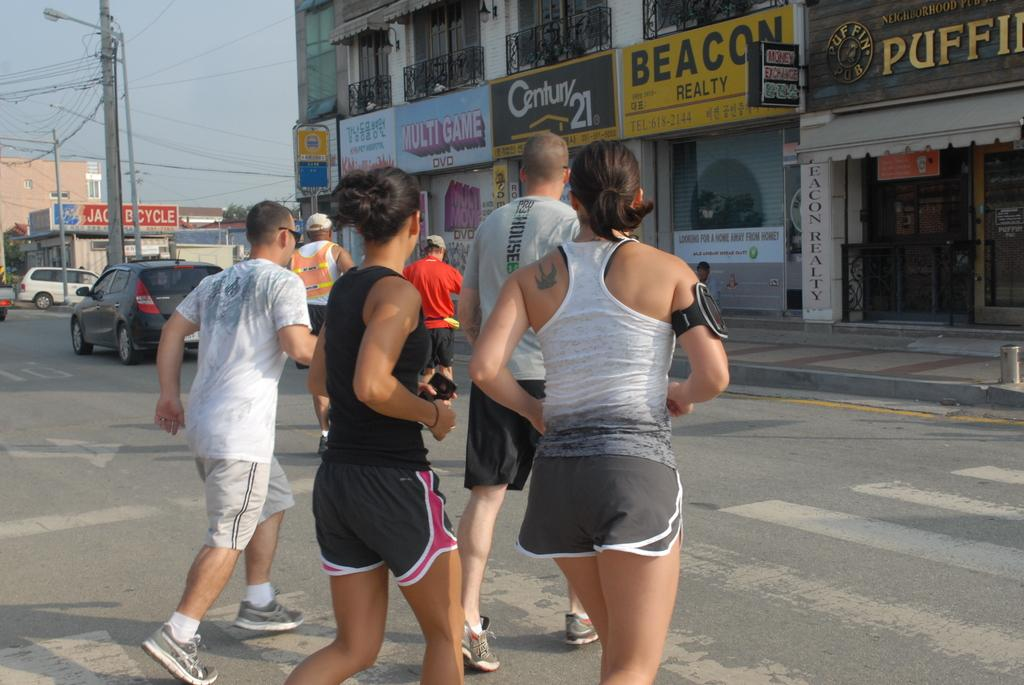Provide a one-sentence caption for the provided image. A group of two male joggers and two female joggers run across a street toward Beacon Realty. 